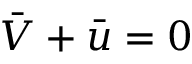<formula> <loc_0><loc_0><loc_500><loc_500>\bar { V } + \bar { u } = 0</formula> 